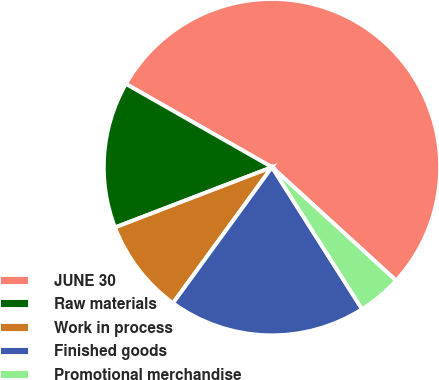Convert chart to OTSL. <chart><loc_0><loc_0><loc_500><loc_500><pie_chart><fcel>JUNE 30<fcel>Raw materials<fcel>Work in process<fcel>Finished goods<fcel>Promotional merchandise<nl><fcel>53.53%<fcel>14.08%<fcel>9.15%<fcel>19.01%<fcel>4.22%<nl></chart> 